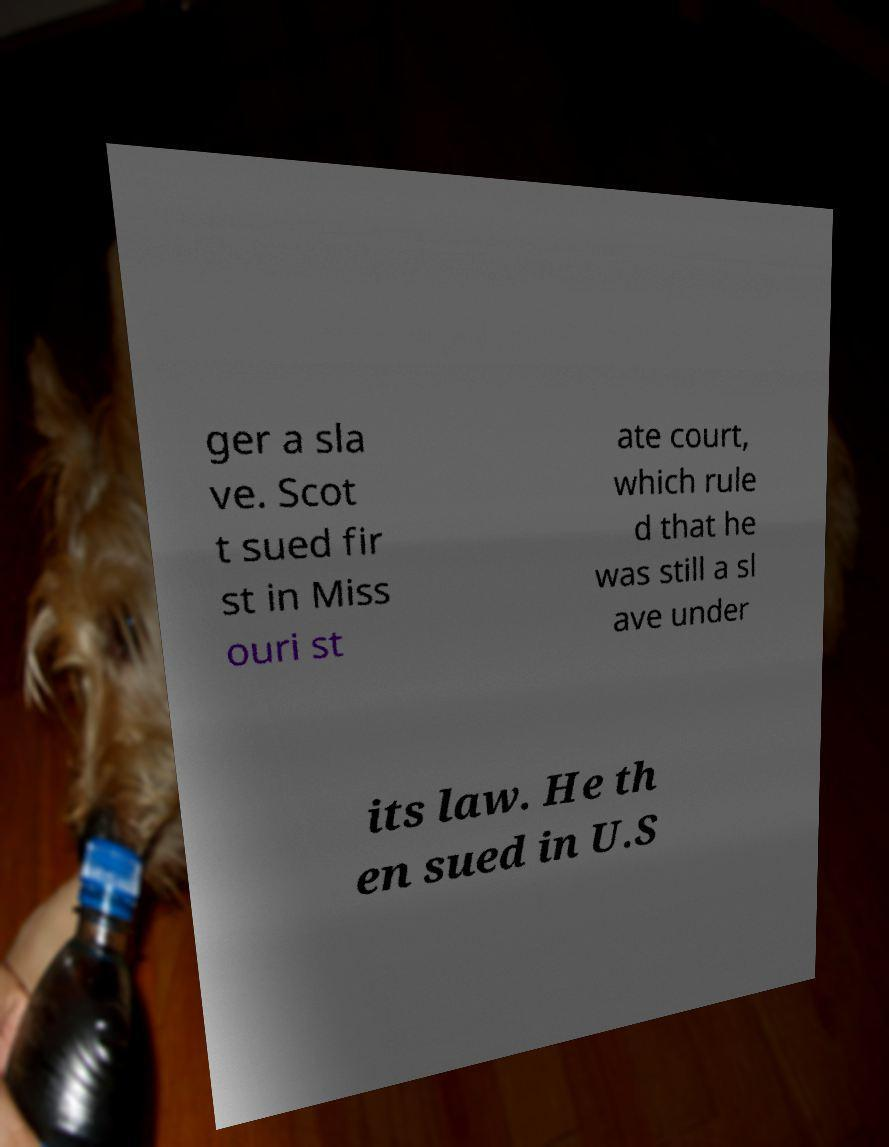Could you assist in decoding the text presented in this image and type it out clearly? ger a sla ve. Scot t sued fir st in Miss ouri st ate court, which rule d that he was still a sl ave under its law. He th en sued in U.S 